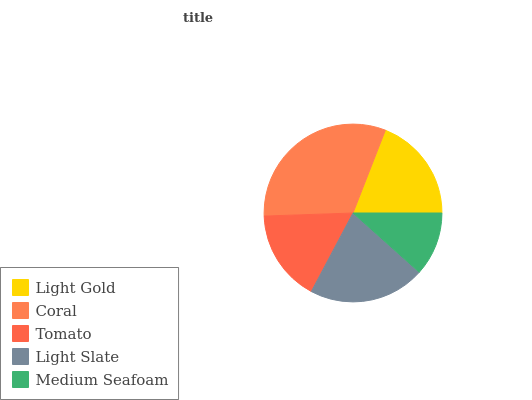Is Medium Seafoam the minimum?
Answer yes or no. Yes. Is Coral the maximum?
Answer yes or no. Yes. Is Tomato the minimum?
Answer yes or no. No. Is Tomato the maximum?
Answer yes or no. No. Is Coral greater than Tomato?
Answer yes or no. Yes. Is Tomato less than Coral?
Answer yes or no. Yes. Is Tomato greater than Coral?
Answer yes or no. No. Is Coral less than Tomato?
Answer yes or no. No. Is Light Gold the high median?
Answer yes or no. Yes. Is Light Gold the low median?
Answer yes or no. Yes. Is Medium Seafoam the high median?
Answer yes or no. No. Is Medium Seafoam the low median?
Answer yes or no. No. 